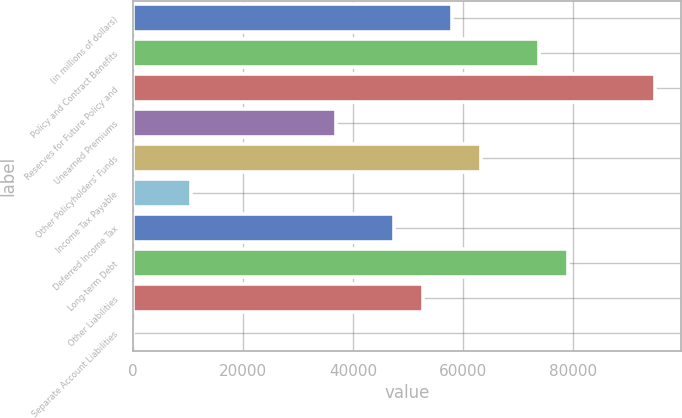<chart> <loc_0><loc_0><loc_500><loc_500><bar_chart><fcel>(in millions of dollars)<fcel>Policy and Contract Benefits<fcel>Reserves for Future Policy and<fcel>Unearned Premiums<fcel>Other Policyholders' Funds<fcel>Income Tax Payable<fcel>Deferred Income Tax<fcel>Long-term Debt<fcel>Other Liabilities<fcel>Separate Account Liabilities<nl><fcel>58102.8<fcel>73941.2<fcel>95059.1<fcel>36984.9<fcel>63382.3<fcel>10587.5<fcel>47543.8<fcel>79220.7<fcel>52823.3<fcel>28.5<nl></chart> 